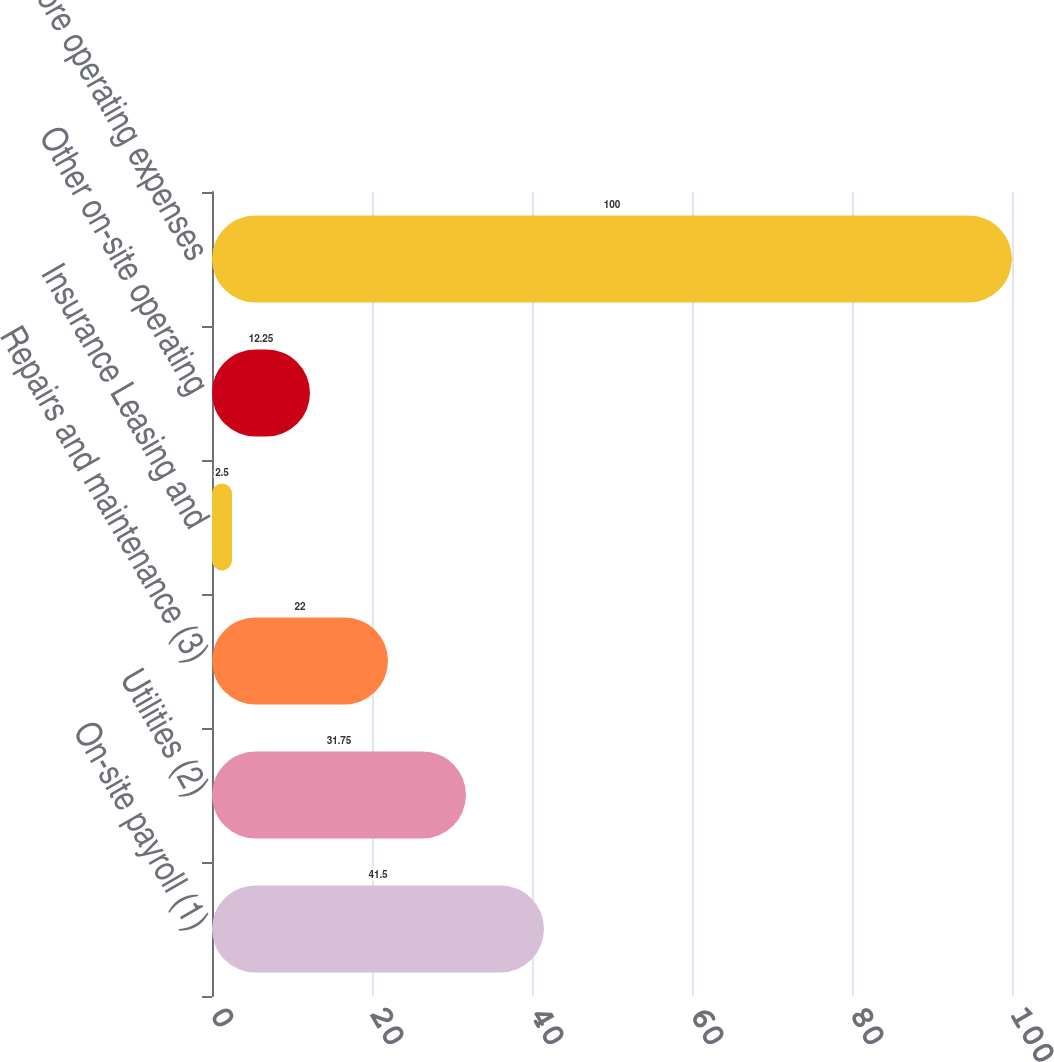<chart> <loc_0><loc_0><loc_500><loc_500><bar_chart><fcel>On-site payroll (1)<fcel>Utilities (2)<fcel>Repairs and maintenance (3)<fcel>Insurance Leasing and<fcel>Other on-site operating<fcel>Same store operating expenses<nl><fcel>41.5<fcel>31.75<fcel>22<fcel>2.5<fcel>12.25<fcel>100<nl></chart> 